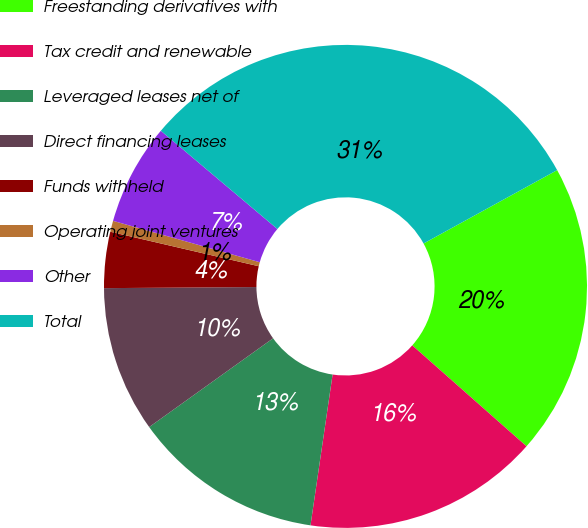Convert chart. <chart><loc_0><loc_0><loc_500><loc_500><pie_chart><fcel>Freestanding derivatives with<fcel>Tax credit and renewable<fcel>Leveraged leases net of<fcel>Direct financing leases<fcel>Funds withheld<fcel>Operating joint ventures<fcel>Other<fcel>Total<nl><fcel>19.51%<fcel>15.8%<fcel>12.79%<fcel>9.78%<fcel>3.75%<fcel>0.74%<fcel>6.77%<fcel>30.86%<nl></chart> 